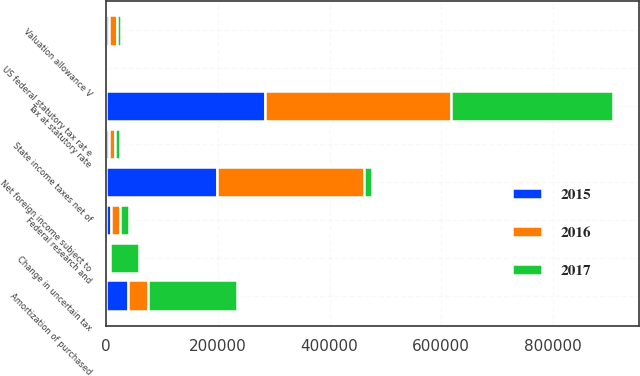<chart> <loc_0><loc_0><loc_500><loc_500><stacked_bar_chart><ecel><fcel>US federal statutory tax rat e<fcel>Tax at statutory rate<fcel>Net foreign income subject to<fcel>State income taxes net of<fcel>Valuation allowance V<fcel>Federal research and<fcel>Change in uncertain tax<fcel>Amortization of purchased<nl><fcel>2017<fcel>35<fcel>289970<fcel>13658<fcel>8801<fcel>7778<fcel>16475<fcel>51088<fcel>159466<nl><fcel>2016<fcel>35<fcel>334922<fcel>264157<fcel>10821<fcel>13658<fcel>16237<fcel>4797<fcel>35641<nl><fcel>2015<fcel>35<fcel>283540<fcel>198061<fcel>4425<fcel>4875<fcel>8232<fcel>2449<fcel>38973<nl></chart> 